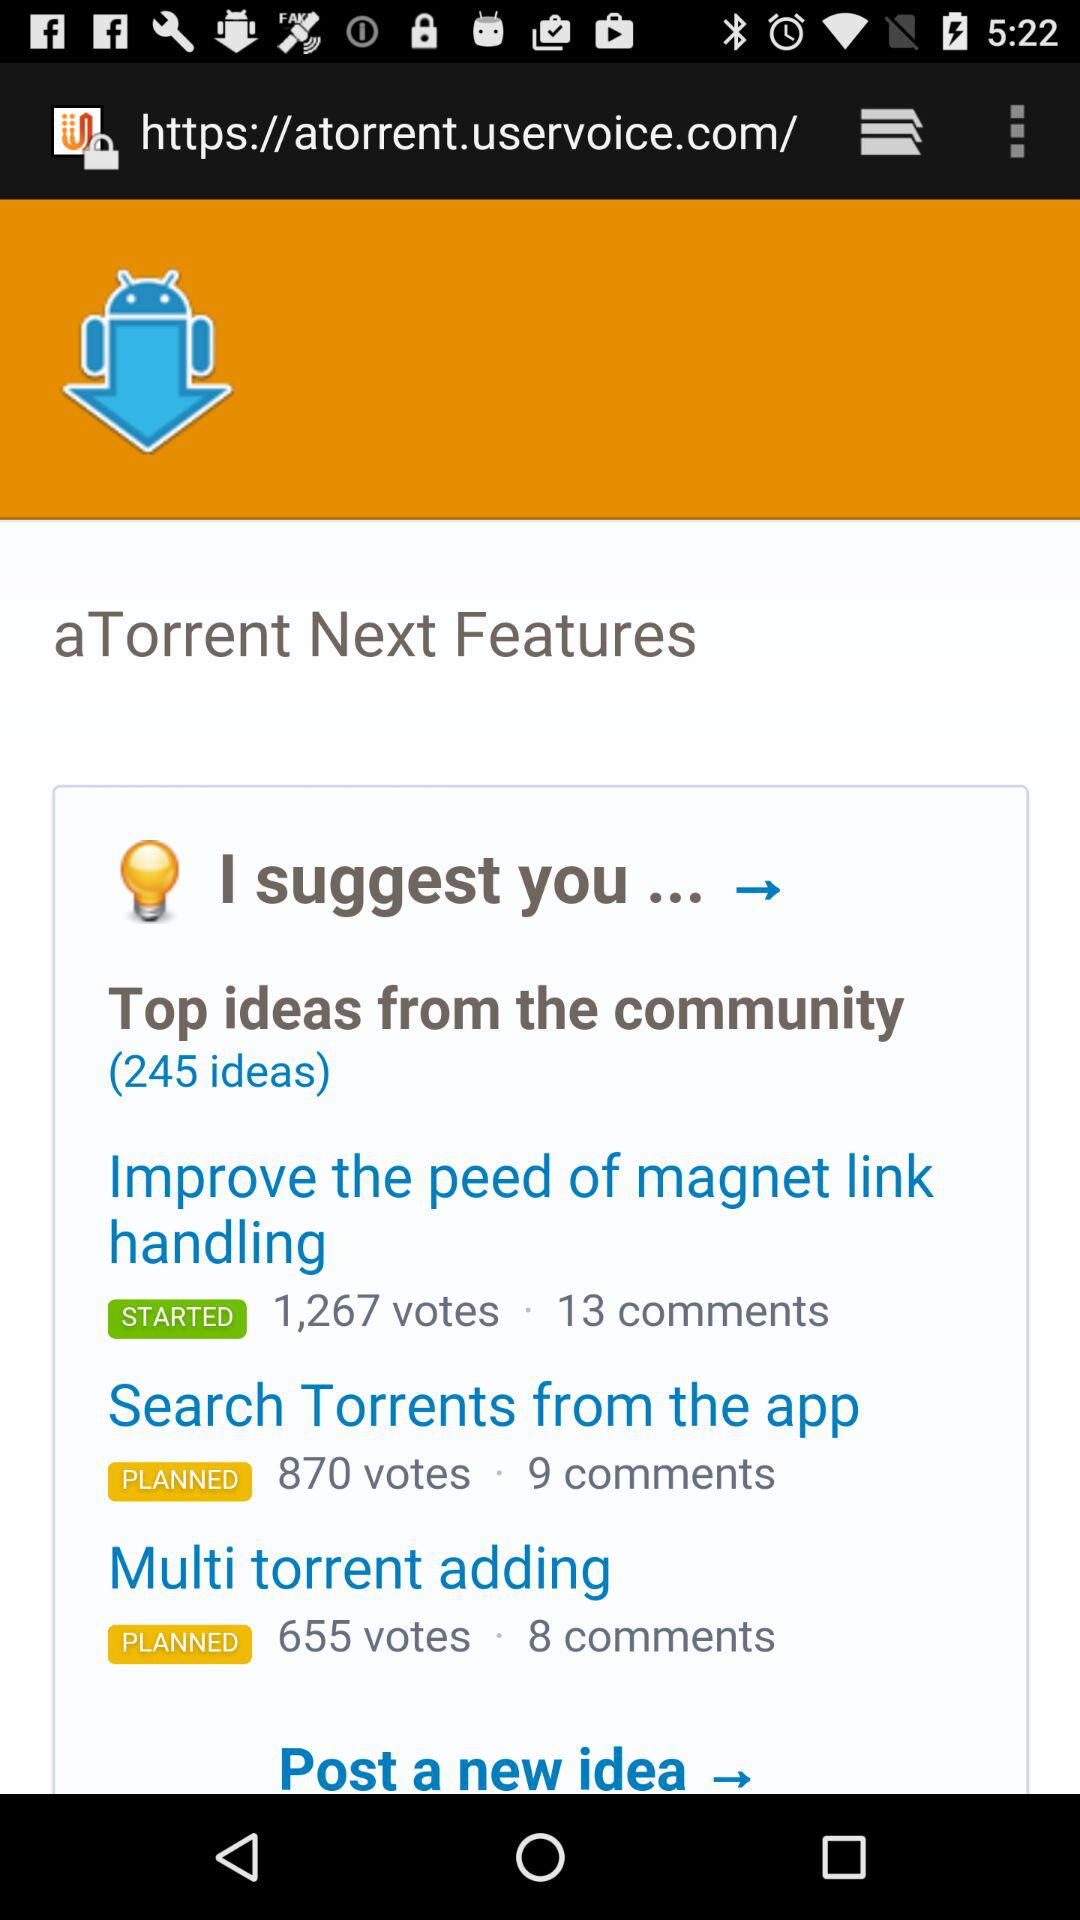How many votes does the idea with the most votes have?
Answer the question using a single word or phrase. 1,267 